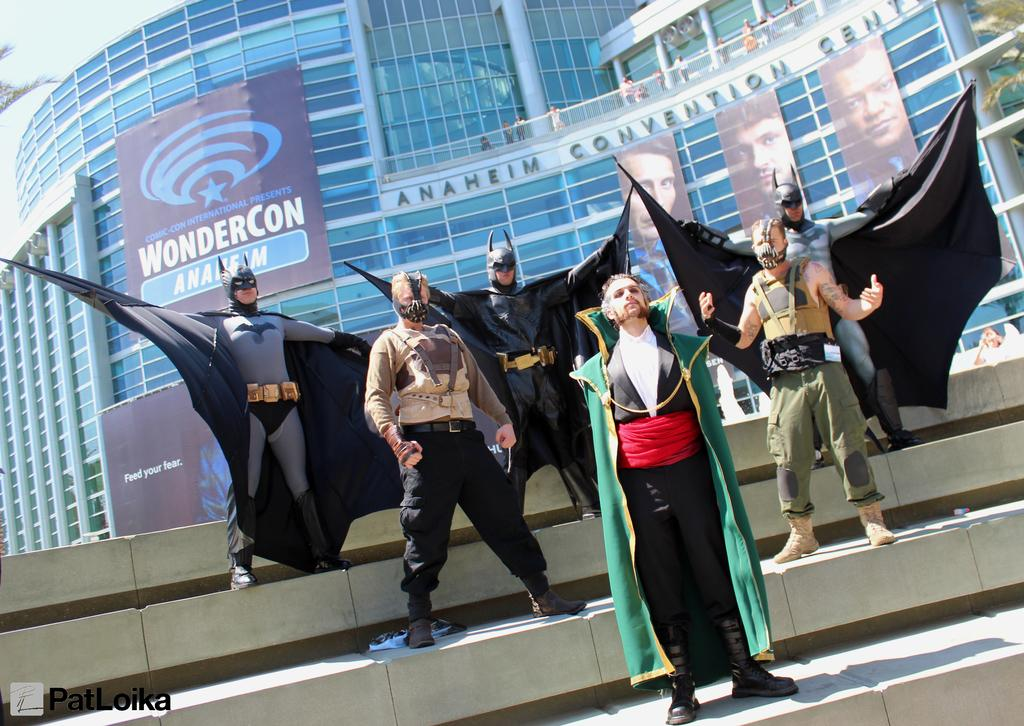What is happening in the foreground of the picture? There are people in various costumes in the foreground of the picture. Where are the people in the foreground located? The people are on a staircase. What can be seen in the background of the image? There are buildings, people, banners, trees, and the sky visible in the background of the image. How many cows are visible in the image? There are no cows present in the image. What type of tooth is being used to crush the banners in the background? There is no tooth present in the image, and the banners are not being crushed. 